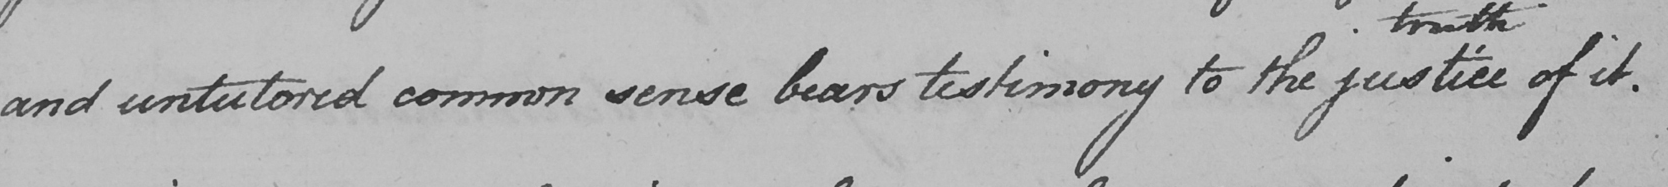What text is written in this handwritten line? and untutored common sense bears testimony to the justice of it . 